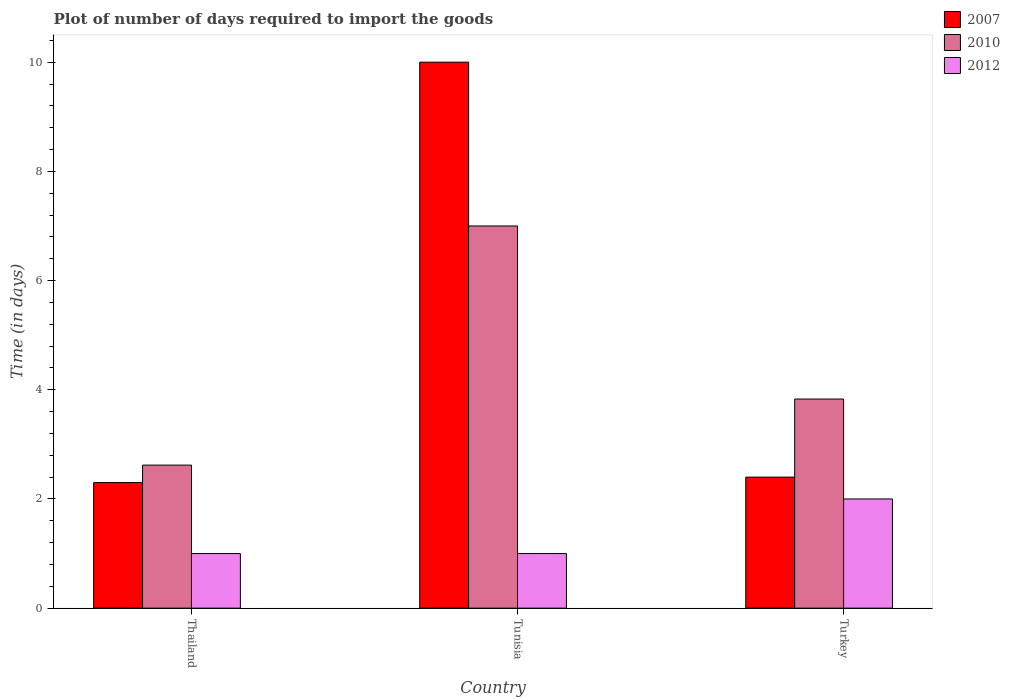How many different coloured bars are there?
Give a very brief answer. 3. How many groups of bars are there?
Your answer should be very brief. 3. Are the number of bars per tick equal to the number of legend labels?
Keep it short and to the point. Yes. Are the number of bars on each tick of the X-axis equal?
Your response must be concise. Yes. How many bars are there on the 1st tick from the left?
Offer a terse response. 3. What is the label of the 2nd group of bars from the left?
Make the answer very short. Tunisia. In how many cases, is the number of bars for a given country not equal to the number of legend labels?
Offer a very short reply. 0. What is the time required to import goods in 2012 in Tunisia?
Provide a succinct answer. 1. Across all countries, what is the maximum time required to import goods in 2007?
Your response must be concise. 10. Across all countries, what is the minimum time required to import goods in 2010?
Offer a very short reply. 2.62. In which country was the time required to import goods in 2007 maximum?
Your answer should be compact. Tunisia. In which country was the time required to import goods in 2012 minimum?
Make the answer very short. Thailand. What is the total time required to import goods in 2010 in the graph?
Make the answer very short. 13.45. What is the difference between the time required to import goods in 2010 in Thailand and that in Tunisia?
Give a very brief answer. -4.38. What is the difference between the time required to import goods in 2010 in Turkey and the time required to import goods in 2012 in Thailand?
Offer a terse response. 2.83. What is the average time required to import goods in 2010 per country?
Give a very brief answer. 4.48. What is the difference between the time required to import goods of/in 2007 and time required to import goods of/in 2010 in Turkey?
Provide a succinct answer. -1.43. In how many countries, is the time required to import goods in 2012 greater than 0.8 days?
Give a very brief answer. 3. What is the ratio of the time required to import goods in 2007 in Thailand to that in Turkey?
Your response must be concise. 0.96. Is the difference between the time required to import goods in 2007 in Thailand and Tunisia greater than the difference between the time required to import goods in 2010 in Thailand and Tunisia?
Offer a terse response. No. What is the difference between the highest and the lowest time required to import goods in 2007?
Keep it short and to the point. 7.7. In how many countries, is the time required to import goods in 2010 greater than the average time required to import goods in 2010 taken over all countries?
Offer a terse response. 1. Is the sum of the time required to import goods in 2007 in Thailand and Turkey greater than the maximum time required to import goods in 2010 across all countries?
Offer a terse response. No. What does the 2nd bar from the left in Thailand represents?
Offer a very short reply. 2010. How many bars are there?
Keep it short and to the point. 9. What is the difference between two consecutive major ticks on the Y-axis?
Give a very brief answer. 2. Are the values on the major ticks of Y-axis written in scientific E-notation?
Your answer should be compact. No. What is the title of the graph?
Keep it short and to the point. Plot of number of days required to import the goods. Does "2010" appear as one of the legend labels in the graph?
Provide a succinct answer. Yes. What is the label or title of the Y-axis?
Your answer should be very brief. Time (in days). What is the Time (in days) of 2007 in Thailand?
Provide a succinct answer. 2.3. What is the Time (in days) in 2010 in Thailand?
Offer a very short reply. 2.62. What is the Time (in days) of 2007 in Tunisia?
Give a very brief answer. 10. What is the Time (in days) of 2010 in Tunisia?
Offer a terse response. 7. What is the Time (in days) of 2012 in Tunisia?
Keep it short and to the point. 1. What is the Time (in days) in 2007 in Turkey?
Provide a short and direct response. 2.4. What is the Time (in days) in 2010 in Turkey?
Keep it short and to the point. 3.83. What is the Time (in days) in 2012 in Turkey?
Provide a short and direct response. 2. Across all countries, what is the minimum Time (in days) of 2007?
Give a very brief answer. 2.3. Across all countries, what is the minimum Time (in days) of 2010?
Keep it short and to the point. 2.62. Across all countries, what is the minimum Time (in days) in 2012?
Your answer should be compact. 1. What is the total Time (in days) of 2007 in the graph?
Your answer should be very brief. 14.7. What is the total Time (in days) of 2010 in the graph?
Provide a short and direct response. 13.45. What is the difference between the Time (in days) in 2007 in Thailand and that in Tunisia?
Provide a short and direct response. -7.7. What is the difference between the Time (in days) in 2010 in Thailand and that in Tunisia?
Keep it short and to the point. -4.38. What is the difference between the Time (in days) in 2012 in Thailand and that in Tunisia?
Keep it short and to the point. 0. What is the difference between the Time (in days) in 2010 in Thailand and that in Turkey?
Keep it short and to the point. -1.21. What is the difference between the Time (in days) in 2012 in Thailand and that in Turkey?
Your answer should be compact. -1. What is the difference between the Time (in days) of 2010 in Tunisia and that in Turkey?
Your response must be concise. 3.17. What is the difference between the Time (in days) of 2007 in Thailand and the Time (in days) of 2010 in Tunisia?
Offer a terse response. -4.7. What is the difference between the Time (in days) in 2007 in Thailand and the Time (in days) in 2012 in Tunisia?
Offer a terse response. 1.3. What is the difference between the Time (in days) of 2010 in Thailand and the Time (in days) of 2012 in Tunisia?
Offer a very short reply. 1.62. What is the difference between the Time (in days) of 2007 in Thailand and the Time (in days) of 2010 in Turkey?
Your response must be concise. -1.53. What is the difference between the Time (in days) of 2007 in Thailand and the Time (in days) of 2012 in Turkey?
Give a very brief answer. 0.3. What is the difference between the Time (in days) in 2010 in Thailand and the Time (in days) in 2012 in Turkey?
Ensure brevity in your answer.  0.62. What is the difference between the Time (in days) of 2007 in Tunisia and the Time (in days) of 2010 in Turkey?
Provide a succinct answer. 6.17. What is the difference between the Time (in days) in 2007 in Tunisia and the Time (in days) in 2012 in Turkey?
Provide a succinct answer. 8. What is the average Time (in days) of 2010 per country?
Provide a short and direct response. 4.48. What is the average Time (in days) of 2012 per country?
Ensure brevity in your answer.  1.33. What is the difference between the Time (in days) in 2007 and Time (in days) in 2010 in Thailand?
Ensure brevity in your answer.  -0.32. What is the difference between the Time (in days) in 2007 and Time (in days) in 2012 in Thailand?
Your answer should be compact. 1.3. What is the difference between the Time (in days) of 2010 and Time (in days) of 2012 in Thailand?
Offer a terse response. 1.62. What is the difference between the Time (in days) in 2010 and Time (in days) in 2012 in Tunisia?
Offer a very short reply. 6. What is the difference between the Time (in days) in 2007 and Time (in days) in 2010 in Turkey?
Offer a very short reply. -1.43. What is the difference between the Time (in days) in 2010 and Time (in days) in 2012 in Turkey?
Keep it short and to the point. 1.83. What is the ratio of the Time (in days) in 2007 in Thailand to that in Tunisia?
Offer a very short reply. 0.23. What is the ratio of the Time (in days) in 2010 in Thailand to that in Tunisia?
Give a very brief answer. 0.37. What is the ratio of the Time (in days) of 2012 in Thailand to that in Tunisia?
Ensure brevity in your answer.  1. What is the ratio of the Time (in days) in 2007 in Thailand to that in Turkey?
Your answer should be compact. 0.96. What is the ratio of the Time (in days) of 2010 in Thailand to that in Turkey?
Offer a terse response. 0.68. What is the ratio of the Time (in days) of 2007 in Tunisia to that in Turkey?
Offer a terse response. 4.17. What is the ratio of the Time (in days) of 2010 in Tunisia to that in Turkey?
Your answer should be compact. 1.83. What is the ratio of the Time (in days) in 2012 in Tunisia to that in Turkey?
Offer a very short reply. 0.5. What is the difference between the highest and the second highest Time (in days) of 2010?
Give a very brief answer. 3.17. What is the difference between the highest and the lowest Time (in days) in 2010?
Your answer should be very brief. 4.38. What is the difference between the highest and the lowest Time (in days) of 2012?
Give a very brief answer. 1. 